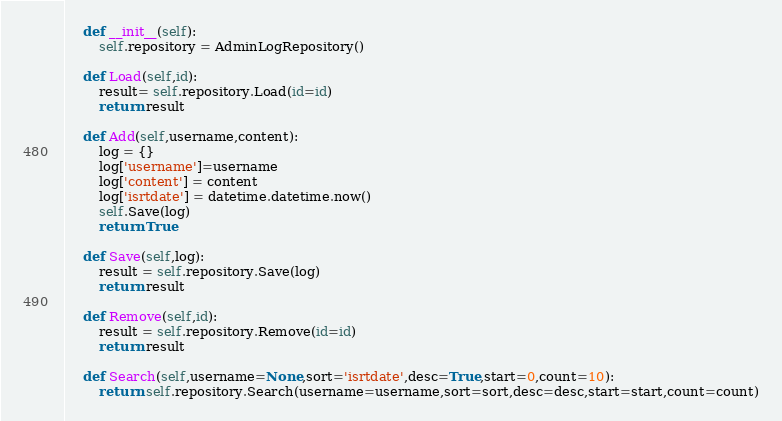<code> <loc_0><loc_0><loc_500><loc_500><_Python_>    def __init__(self):
        self.repository = AdminLogRepository()

    def Load(self,id):
        result= self.repository.Load(id=id)
        return result

    def Add(self,username,content):
        log = {}
        log['username']=username
        log['content'] = content
        log['isrtdate'] = datetime.datetime.now()
        self.Save(log)
        return True

    def Save(self,log):
        result = self.repository.Save(log)
        return result

    def Remove(self,id):
        result = self.repository.Remove(id=id)
        return result

    def Search(self,username=None,sort='isrtdate',desc=True,start=0,count=10):
        return self.repository.Search(username=username,sort=sort,desc=desc,start=start,count=count)</code> 